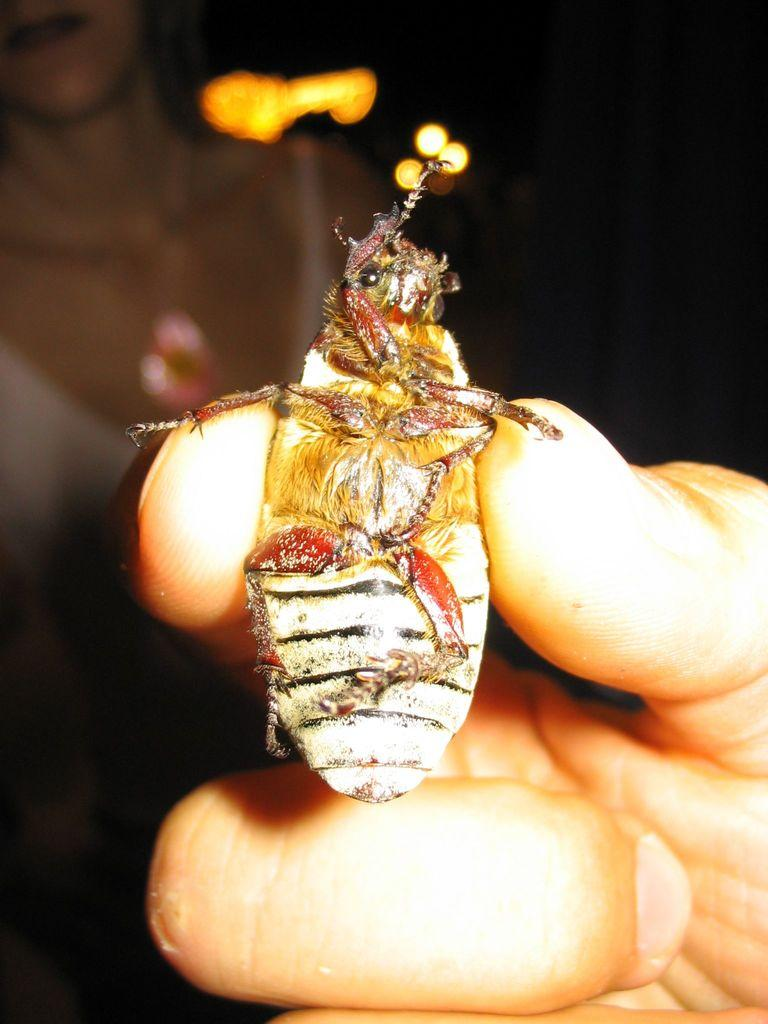What is the main subject of the image? The main subject of the image is a person's hand holding a fly. Can you describe the action taking place in the image? The person's hand is holding a fly in the center of the image. Is there anyone else visible in the image? A: Yes, there is a lady in the background of the image. What type of grape is being held by the person in the image? There is no grape present in the image; the person's hand is holding a fly. How many frogs can be seen in the image? There are no frogs present in the image; the main subject is a person's hand holding a fly. 